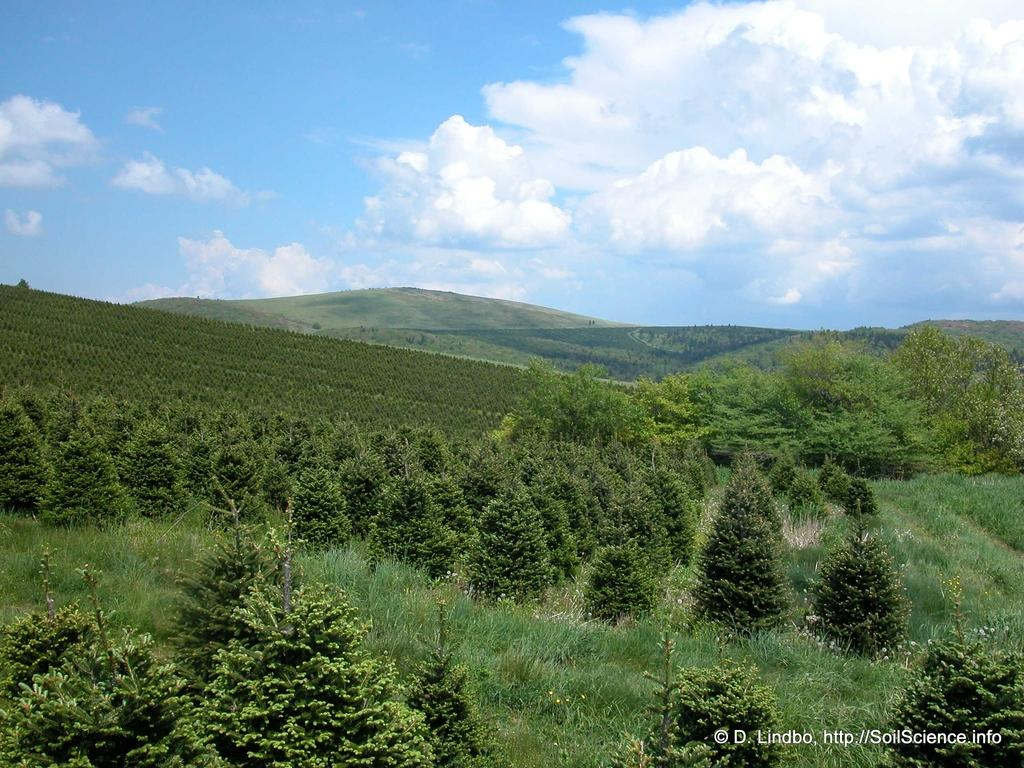What type of natural elements can be seen at the bottom of the image? There are plants, grass, and trees at the bottom of the image. What type of landscape feature is visible in the background of the image? There are mountains visible in the background of the image. What part of the natural environment is visible at the top of the image? The sky is present at the top of the image. Where is the basketball court located in the image? There is no basketball court present in the image. What type of tool is being used to construct the road in the image? There is no road or tool present in the image. 